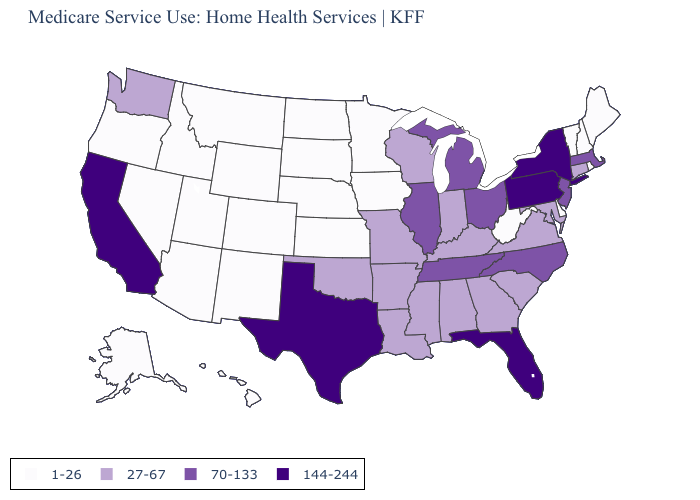Name the states that have a value in the range 144-244?
Short answer required. California, Florida, New York, Pennsylvania, Texas. Name the states that have a value in the range 1-26?
Write a very short answer. Alaska, Arizona, Colorado, Delaware, Hawaii, Idaho, Iowa, Kansas, Maine, Minnesota, Montana, Nebraska, Nevada, New Hampshire, New Mexico, North Dakota, Oregon, Rhode Island, South Dakota, Utah, Vermont, West Virginia, Wyoming. What is the value of New Jersey?
Quick response, please. 70-133. Does Missouri have the highest value in the MidWest?
Keep it brief. No. Does Kentucky have a lower value than Georgia?
Write a very short answer. No. What is the lowest value in the West?
Concise answer only. 1-26. What is the value of Hawaii?
Be succinct. 1-26. What is the highest value in the USA?
Keep it brief. 144-244. Name the states that have a value in the range 27-67?
Short answer required. Alabama, Arkansas, Connecticut, Georgia, Indiana, Kentucky, Louisiana, Maryland, Mississippi, Missouri, Oklahoma, South Carolina, Virginia, Washington, Wisconsin. Among the states that border Arizona , does California have the highest value?
Write a very short answer. Yes. Does the first symbol in the legend represent the smallest category?
Write a very short answer. Yes. Name the states that have a value in the range 1-26?
Keep it brief. Alaska, Arizona, Colorado, Delaware, Hawaii, Idaho, Iowa, Kansas, Maine, Minnesota, Montana, Nebraska, Nevada, New Hampshire, New Mexico, North Dakota, Oregon, Rhode Island, South Dakota, Utah, Vermont, West Virginia, Wyoming. What is the value of Arkansas?
Write a very short answer. 27-67. What is the lowest value in the Northeast?
Be succinct. 1-26. Name the states that have a value in the range 70-133?
Answer briefly. Illinois, Massachusetts, Michigan, New Jersey, North Carolina, Ohio, Tennessee. 